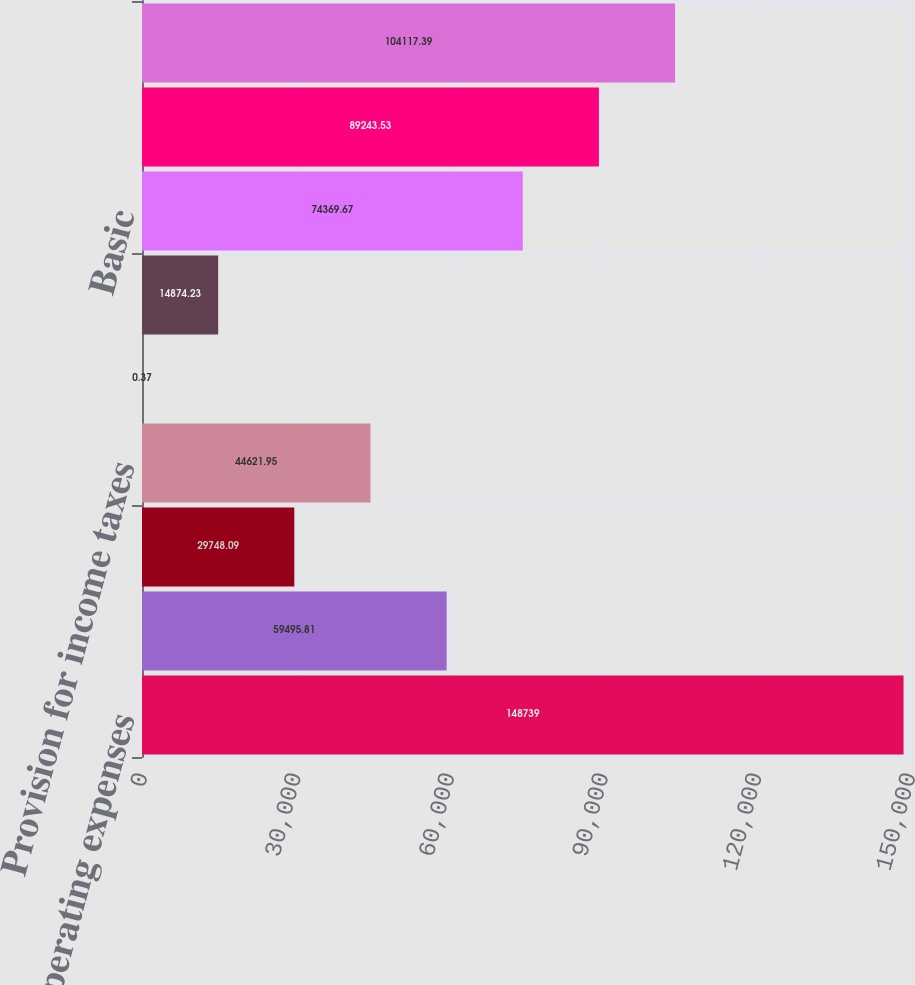<chart> <loc_0><loc_0><loc_500><loc_500><bar_chart><fcel>Total operating expenses<fcel>Operating income<fcel>Interest and other expense<fcel>Provision for income taxes<fcel>Continuing operations<fcel>Earnings per basic common<fcel>Basic<fcel>Diluted<fcel>Trade receivables (net of<nl><fcel>148739<fcel>59495.8<fcel>29748.1<fcel>44621.9<fcel>0.37<fcel>14874.2<fcel>74369.7<fcel>89243.5<fcel>104117<nl></chart> 